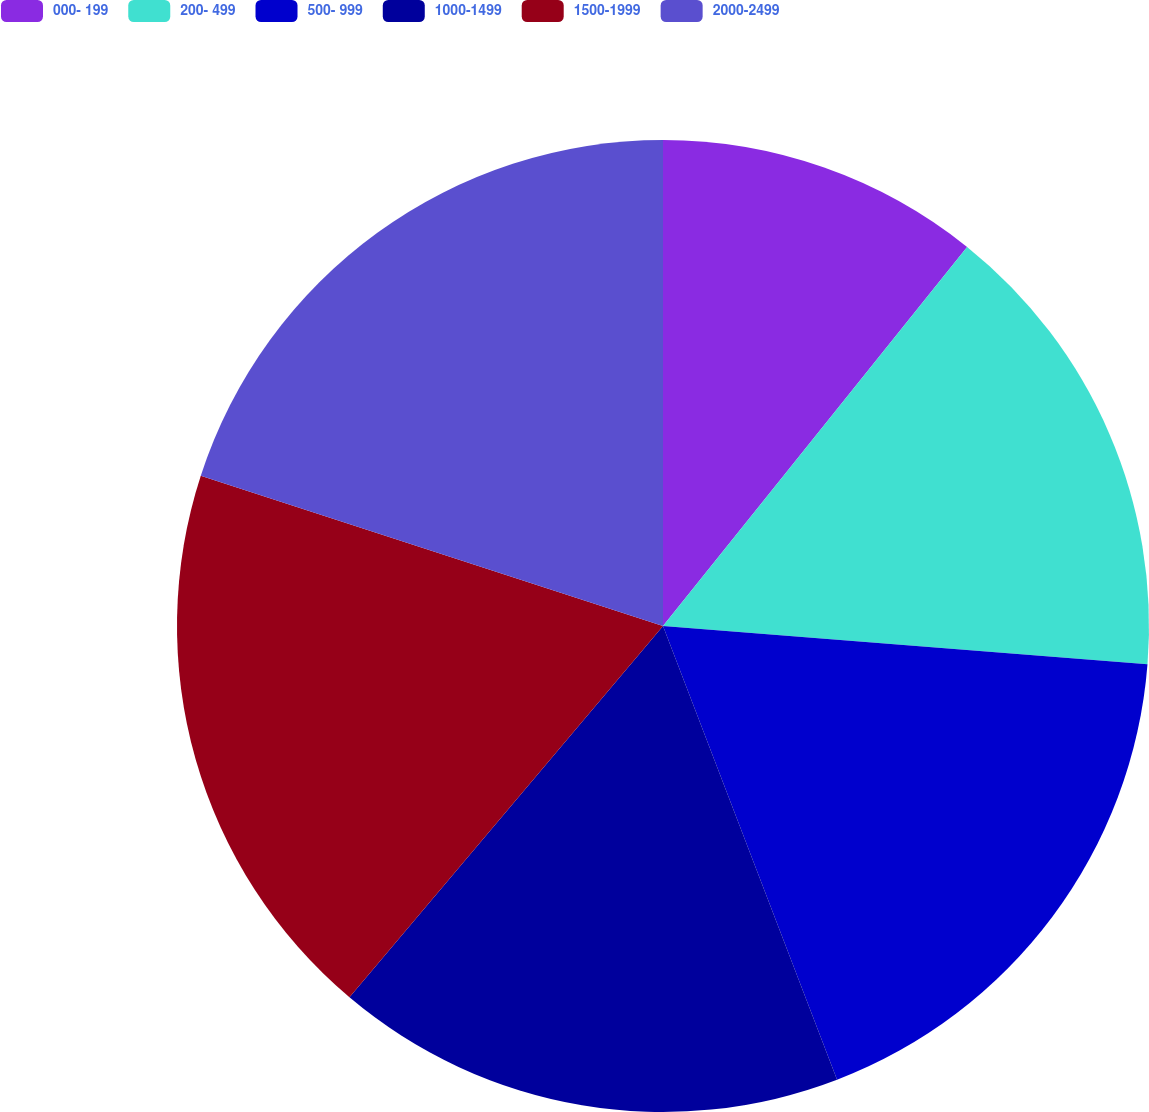Convert chart. <chart><loc_0><loc_0><loc_500><loc_500><pie_chart><fcel>000- 199<fcel>200- 499<fcel>500- 999<fcel>1000-1499<fcel>1500-1999<fcel>2000-2499<nl><fcel>10.76%<fcel>15.49%<fcel>17.92%<fcel>16.99%<fcel>18.84%<fcel>20.0%<nl></chart> 